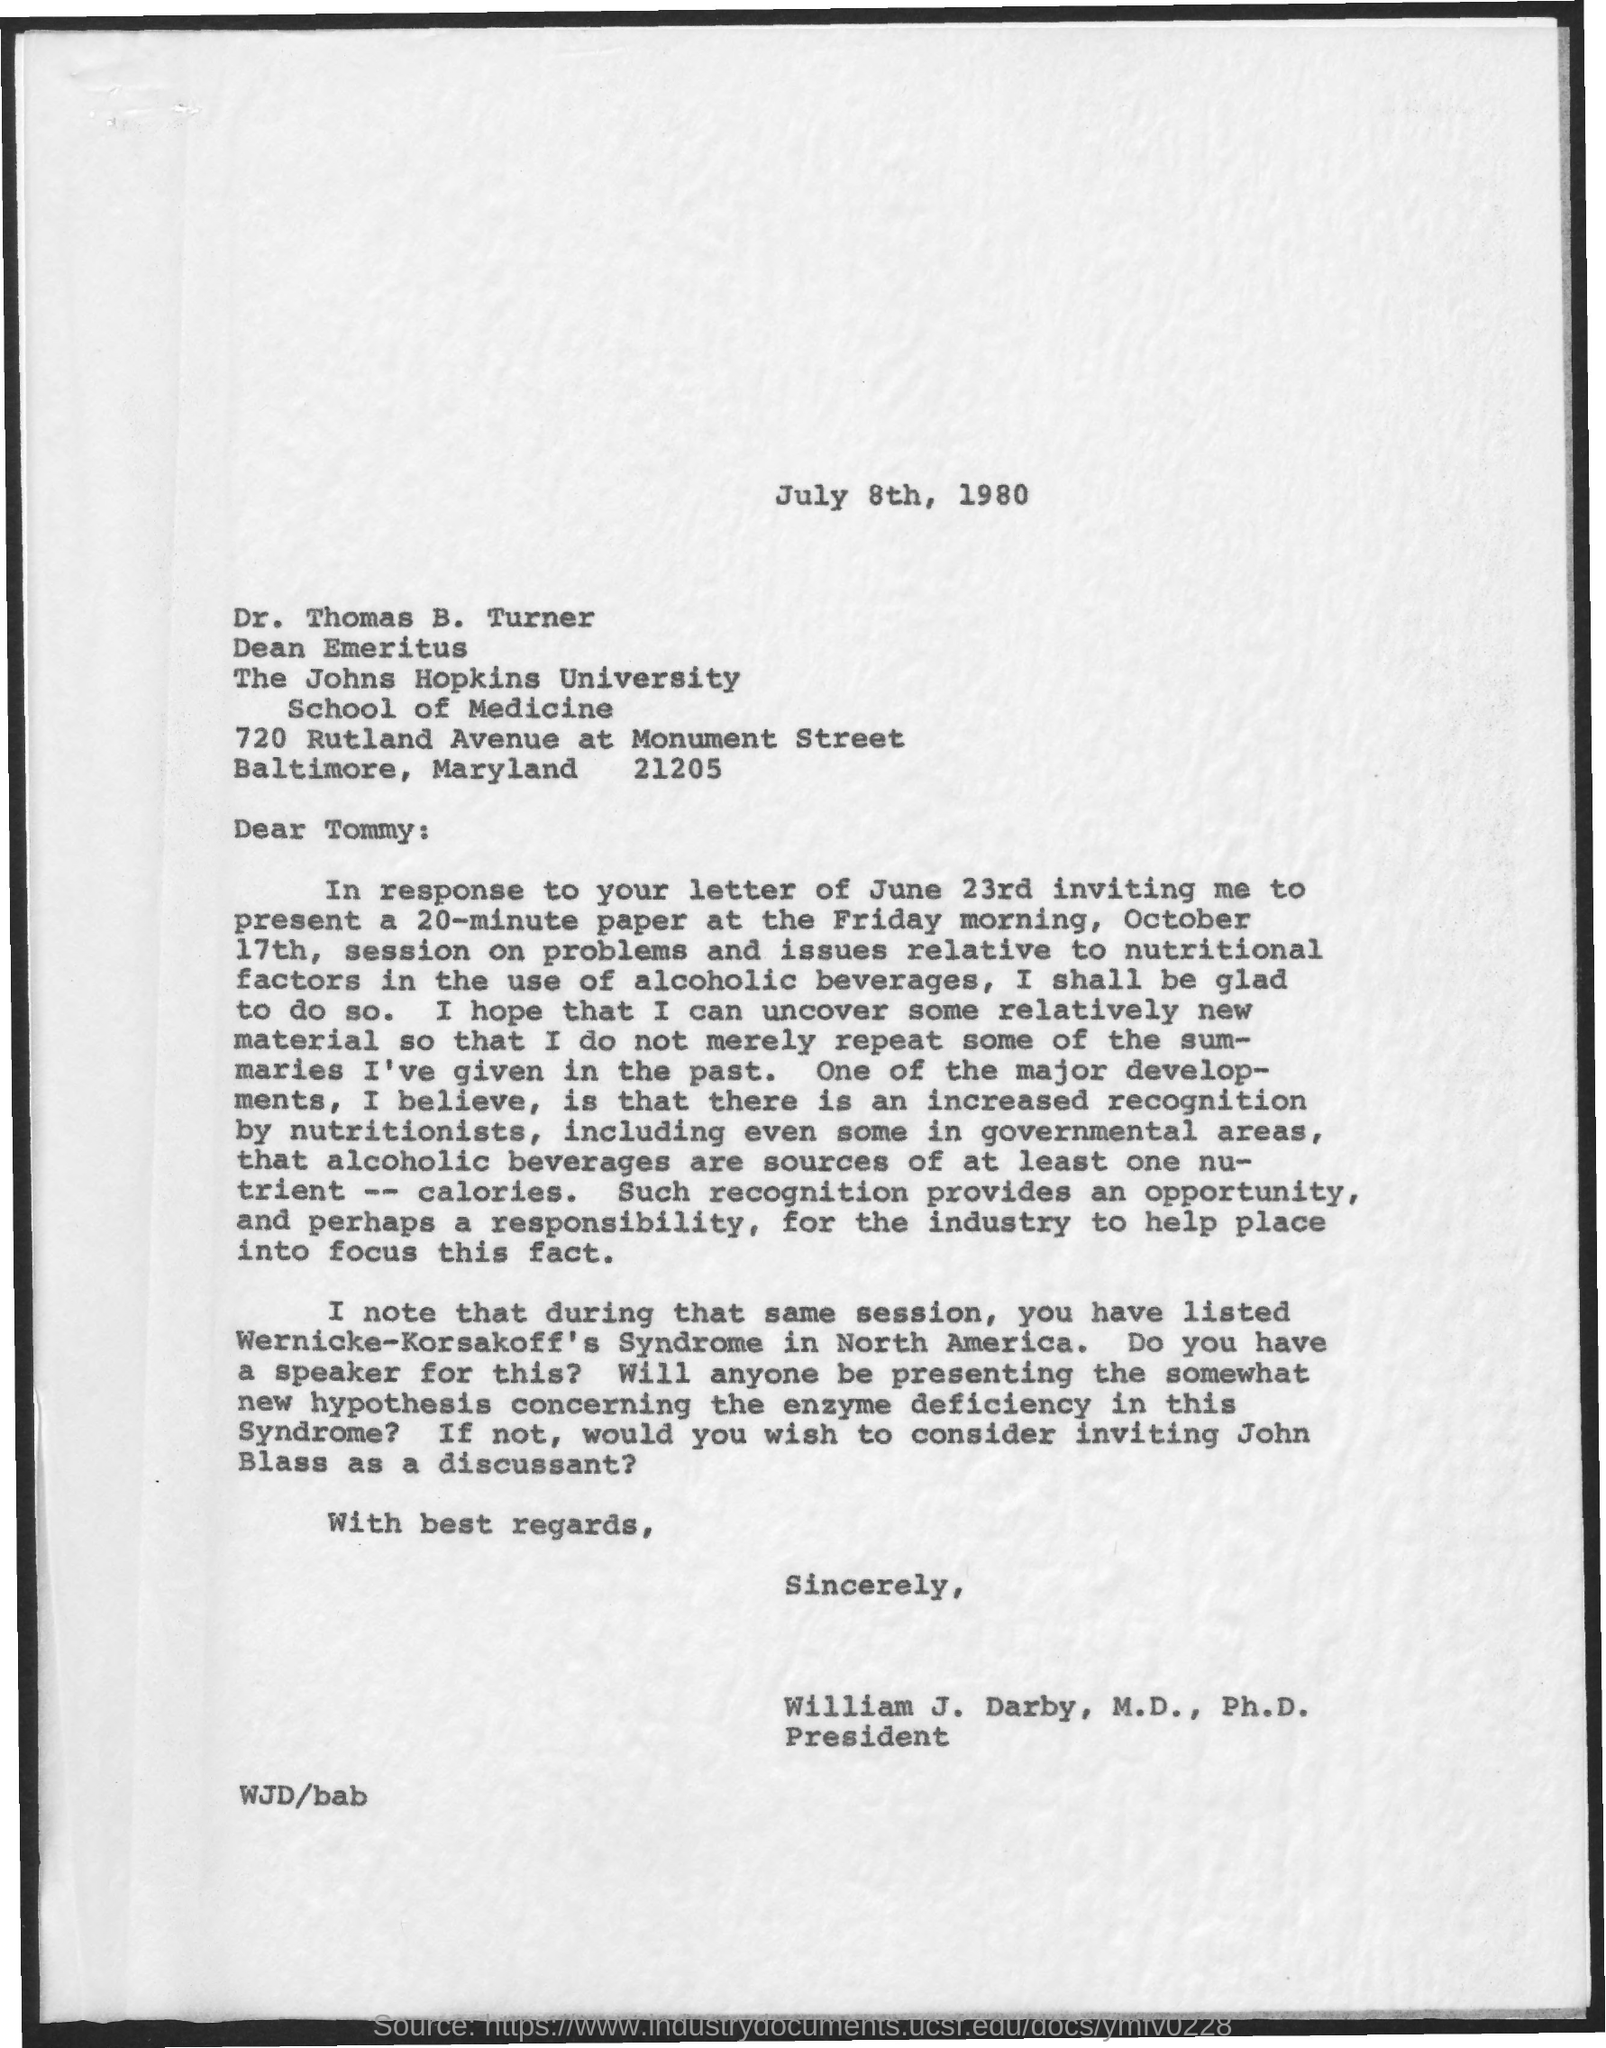To whom is this letter addressed to?
Ensure brevity in your answer.  Dr. Thomas B. Turner. What has been listed during that same session?
Make the answer very short. Wernicke-Korsakoff's Syndrome in North America. 